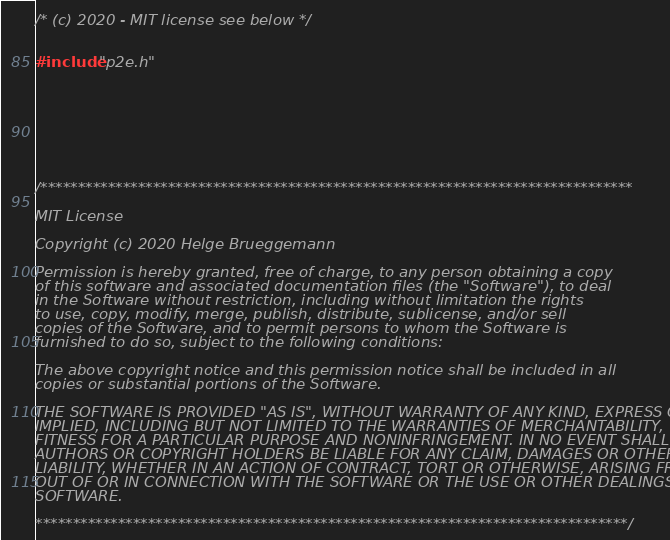Convert code to text. <code><loc_0><loc_0><loc_500><loc_500><_C_>/* (c) 2020 - MIT license see below */


#include "p2e.h"








/*******************************************************************************

MIT License

Copyright (c) 2020 Helge Brueggemann

Permission is hereby granted, free of charge, to any person obtaining a copy
of this software and associated documentation files (the "Software"), to deal
in the Software without restriction, including without limitation the rights
to use, copy, modify, merge, publish, distribute, sublicense, and/or sell
copies of the Software, and to permit persons to whom the Software is
furnished to do so, subject to the following conditions:

The above copyright notice and this permission notice shall be included in all
copies or substantial portions of the Software.

THE SOFTWARE IS PROVIDED "AS IS", WITHOUT WARRANTY OF ANY KIND, EXPRESS OR
IMPLIED, INCLUDING BUT NOT LIMITED TO THE WARRANTIES OF MERCHANTABILITY,
FITNESS FOR A PARTICULAR PURPOSE AND NONINFRINGEMENT. IN NO EVENT SHALL THE
AUTHORS OR COPYRIGHT HOLDERS BE LIABLE FOR ANY CLAIM, DAMAGES OR OTHER
LIABILITY, WHETHER IN AN ACTION OF CONTRACT, TORT OR OTHERWISE, ARISING FROM,
OUT OF OR IN CONNECTION WITH THE SOFTWARE OR THE USE OR OTHER DEALINGS IN THE
SOFTWARE.

*******************************************************************************/
</code> 